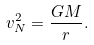<formula> <loc_0><loc_0><loc_500><loc_500>v _ { N } ^ { 2 } = \frac { G M } { r } .</formula> 